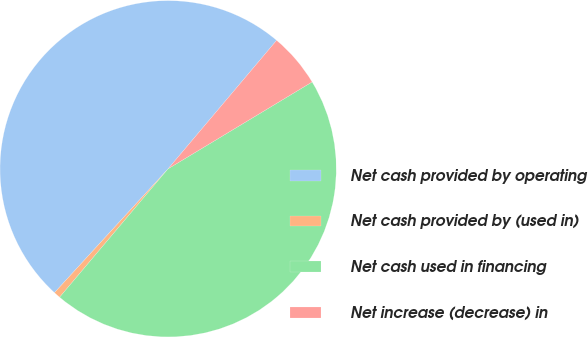Convert chart. <chart><loc_0><loc_0><loc_500><loc_500><pie_chart><fcel>Net cash provided by operating<fcel>Net cash provided by (used in)<fcel>Net cash used in financing<fcel>Net increase (decrease) in<nl><fcel>49.35%<fcel>0.65%<fcel>44.8%<fcel>5.2%<nl></chart> 